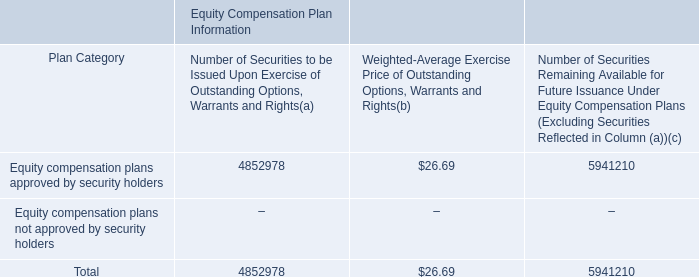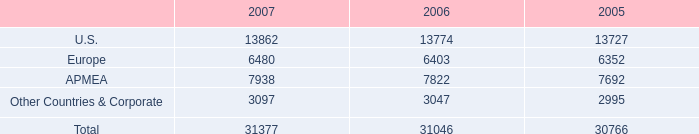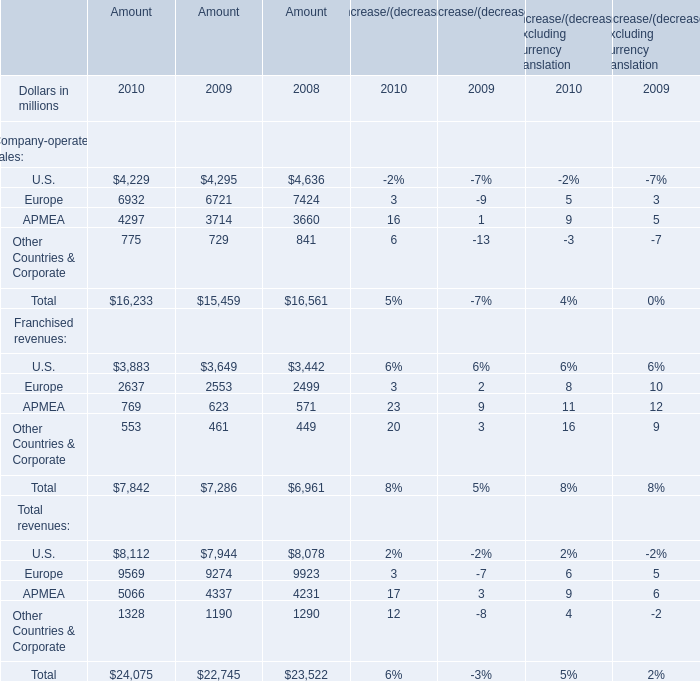What was the Amount of the Total Company-operated sales in the year where the Amount of Total Franchised revenues is smaller than 7000 million? (in million) 
Answer: 16561. 